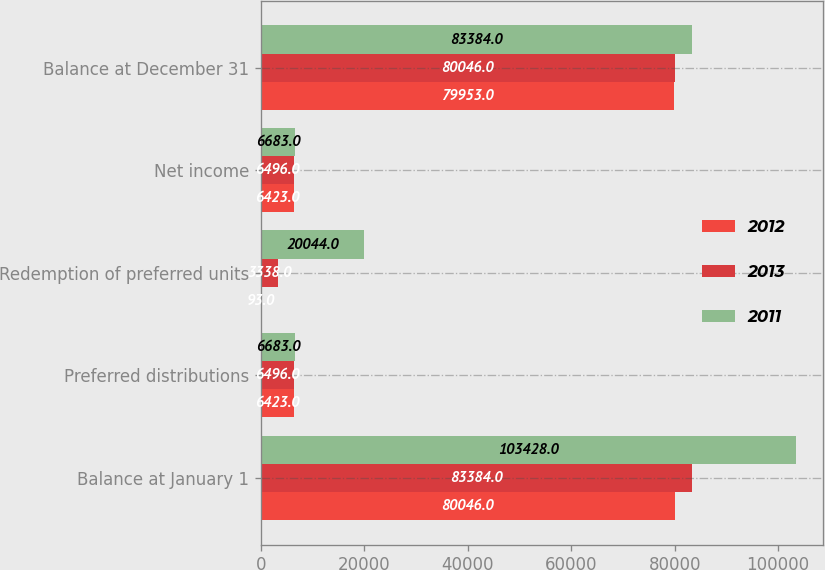Convert chart to OTSL. <chart><loc_0><loc_0><loc_500><loc_500><stacked_bar_chart><ecel><fcel>Balance at January 1<fcel>Preferred distributions<fcel>Redemption of preferred units<fcel>Net income<fcel>Balance at December 31<nl><fcel>2012<fcel>80046<fcel>6423<fcel>93<fcel>6423<fcel>79953<nl><fcel>2013<fcel>83384<fcel>6496<fcel>3338<fcel>6496<fcel>80046<nl><fcel>2011<fcel>103428<fcel>6683<fcel>20044<fcel>6683<fcel>83384<nl></chart> 